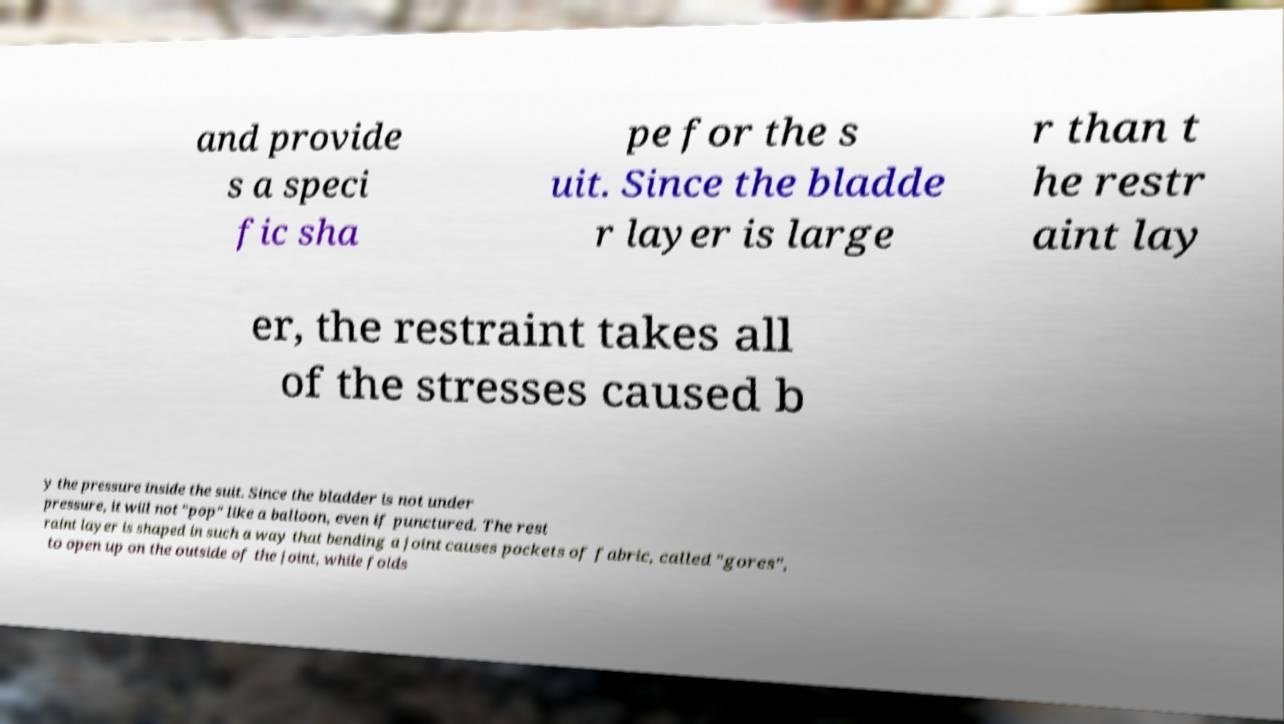For documentation purposes, I need the text within this image transcribed. Could you provide that? and provide s a speci fic sha pe for the s uit. Since the bladde r layer is large r than t he restr aint lay er, the restraint takes all of the stresses caused b y the pressure inside the suit. Since the bladder is not under pressure, it will not "pop" like a balloon, even if punctured. The rest raint layer is shaped in such a way that bending a joint causes pockets of fabric, called "gores", to open up on the outside of the joint, while folds 